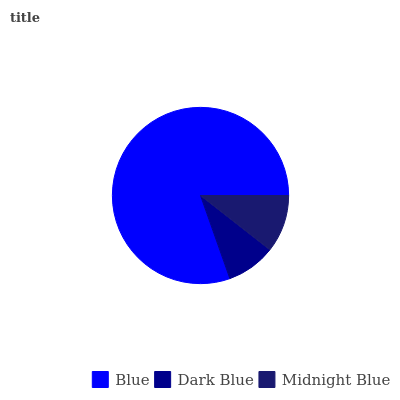Is Dark Blue the minimum?
Answer yes or no. Yes. Is Blue the maximum?
Answer yes or no. Yes. Is Midnight Blue the minimum?
Answer yes or no. No. Is Midnight Blue the maximum?
Answer yes or no. No. Is Midnight Blue greater than Dark Blue?
Answer yes or no. Yes. Is Dark Blue less than Midnight Blue?
Answer yes or no. Yes. Is Dark Blue greater than Midnight Blue?
Answer yes or no. No. Is Midnight Blue less than Dark Blue?
Answer yes or no. No. Is Midnight Blue the high median?
Answer yes or no. Yes. Is Midnight Blue the low median?
Answer yes or no. Yes. Is Blue the high median?
Answer yes or no. No. Is Dark Blue the low median?
Answer yes or no. No. 